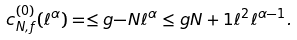<formula> <loc_0><loc_0><loc_500><loc_500>c _ { N , f } ^ { ( 0 ) } ( \ell ^ { \alpha } ) = \leq g { - N } { \ell } ^ { \alpha } \leq g { N + 1 } { \ell } ^ { 2 } \ell ^ { \alpha - 1 } .</formula> 